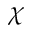Convert formula to latex. <formula><loc_0><loc_0><loc_500><loc_500>\chi</formula> 